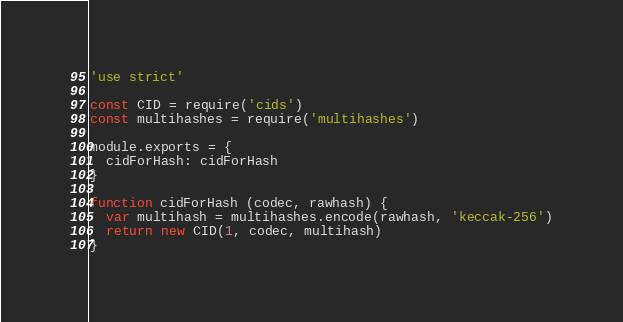Convert code to text. <code><loc_0><loc_0><loc_500><loc_500><_JavaScript_>'use strict'

const CID = require('cids')
const multihashes = require('multihashes')

module.exports = {
  cidForHash: cidForHash
}

function cidForHash (codec, rawhash) {
  var multihash = multihashes.encode(rawhash, 'keccak-256')
  return new CID(1, codec, multihash)
}
</code> 